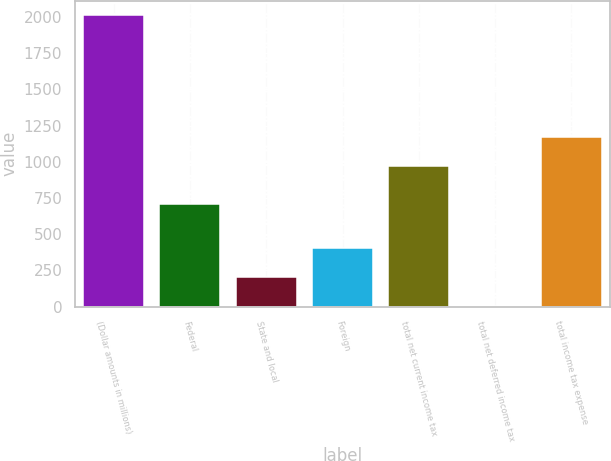Convert chart to OTSL. <chart><loc_0><loc_0><loc_500><loc_500><bar_chart><fcel>(Dollar amounts in millions)<fcel>Federal<fcel>State and local<fcel>Foreign<fcel>total net current income tax<fcel>total net deferred income tax<fcel>total income tax expense<nl><fcel>2010<fcel>708<fcel>203.7<fcel>404.4<fcel>968<fcel>3<fcel>1168.7<nl></chart> 